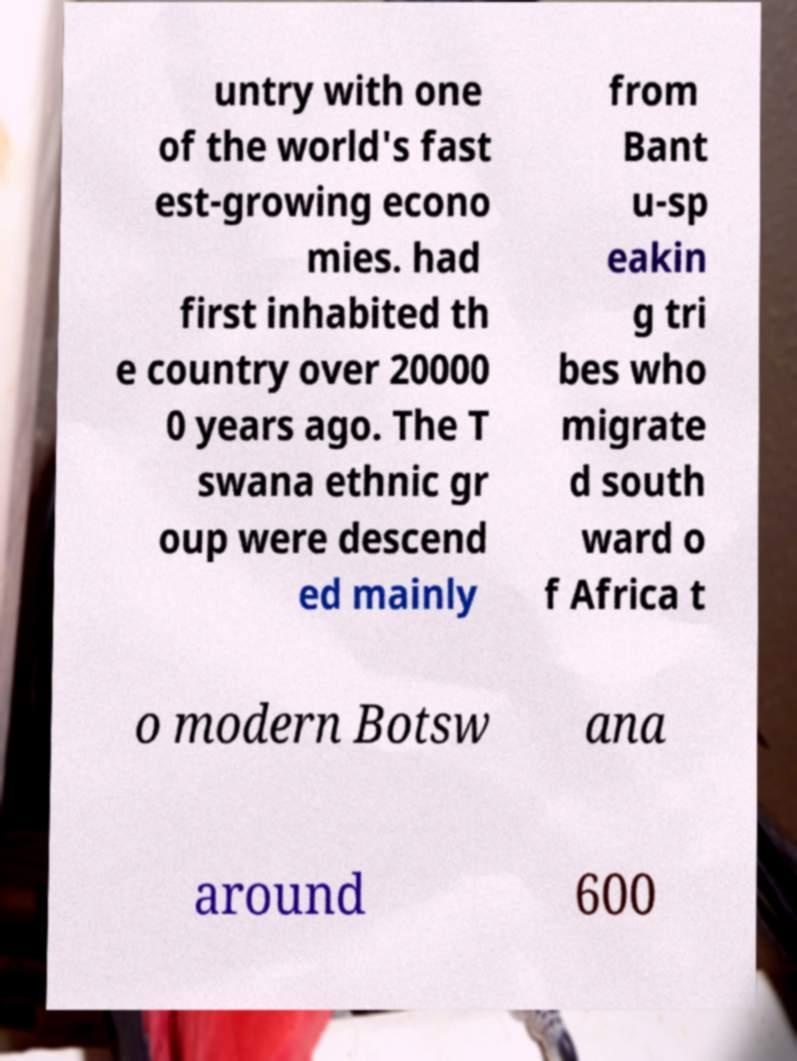Can you read and provide the text displayed in the image?This photo seems to have some interesting text. Can you extract and type it out for me? untry with one of the world's fast est-growing econo mies. had first inhabited th e country over 20000 0 years ago. The T swana ethnic gr oup were descend ed mainly from Bant u-sp eakin g tri bes who migrate d south ward o f Africa t o modern Botsw ana around 600 